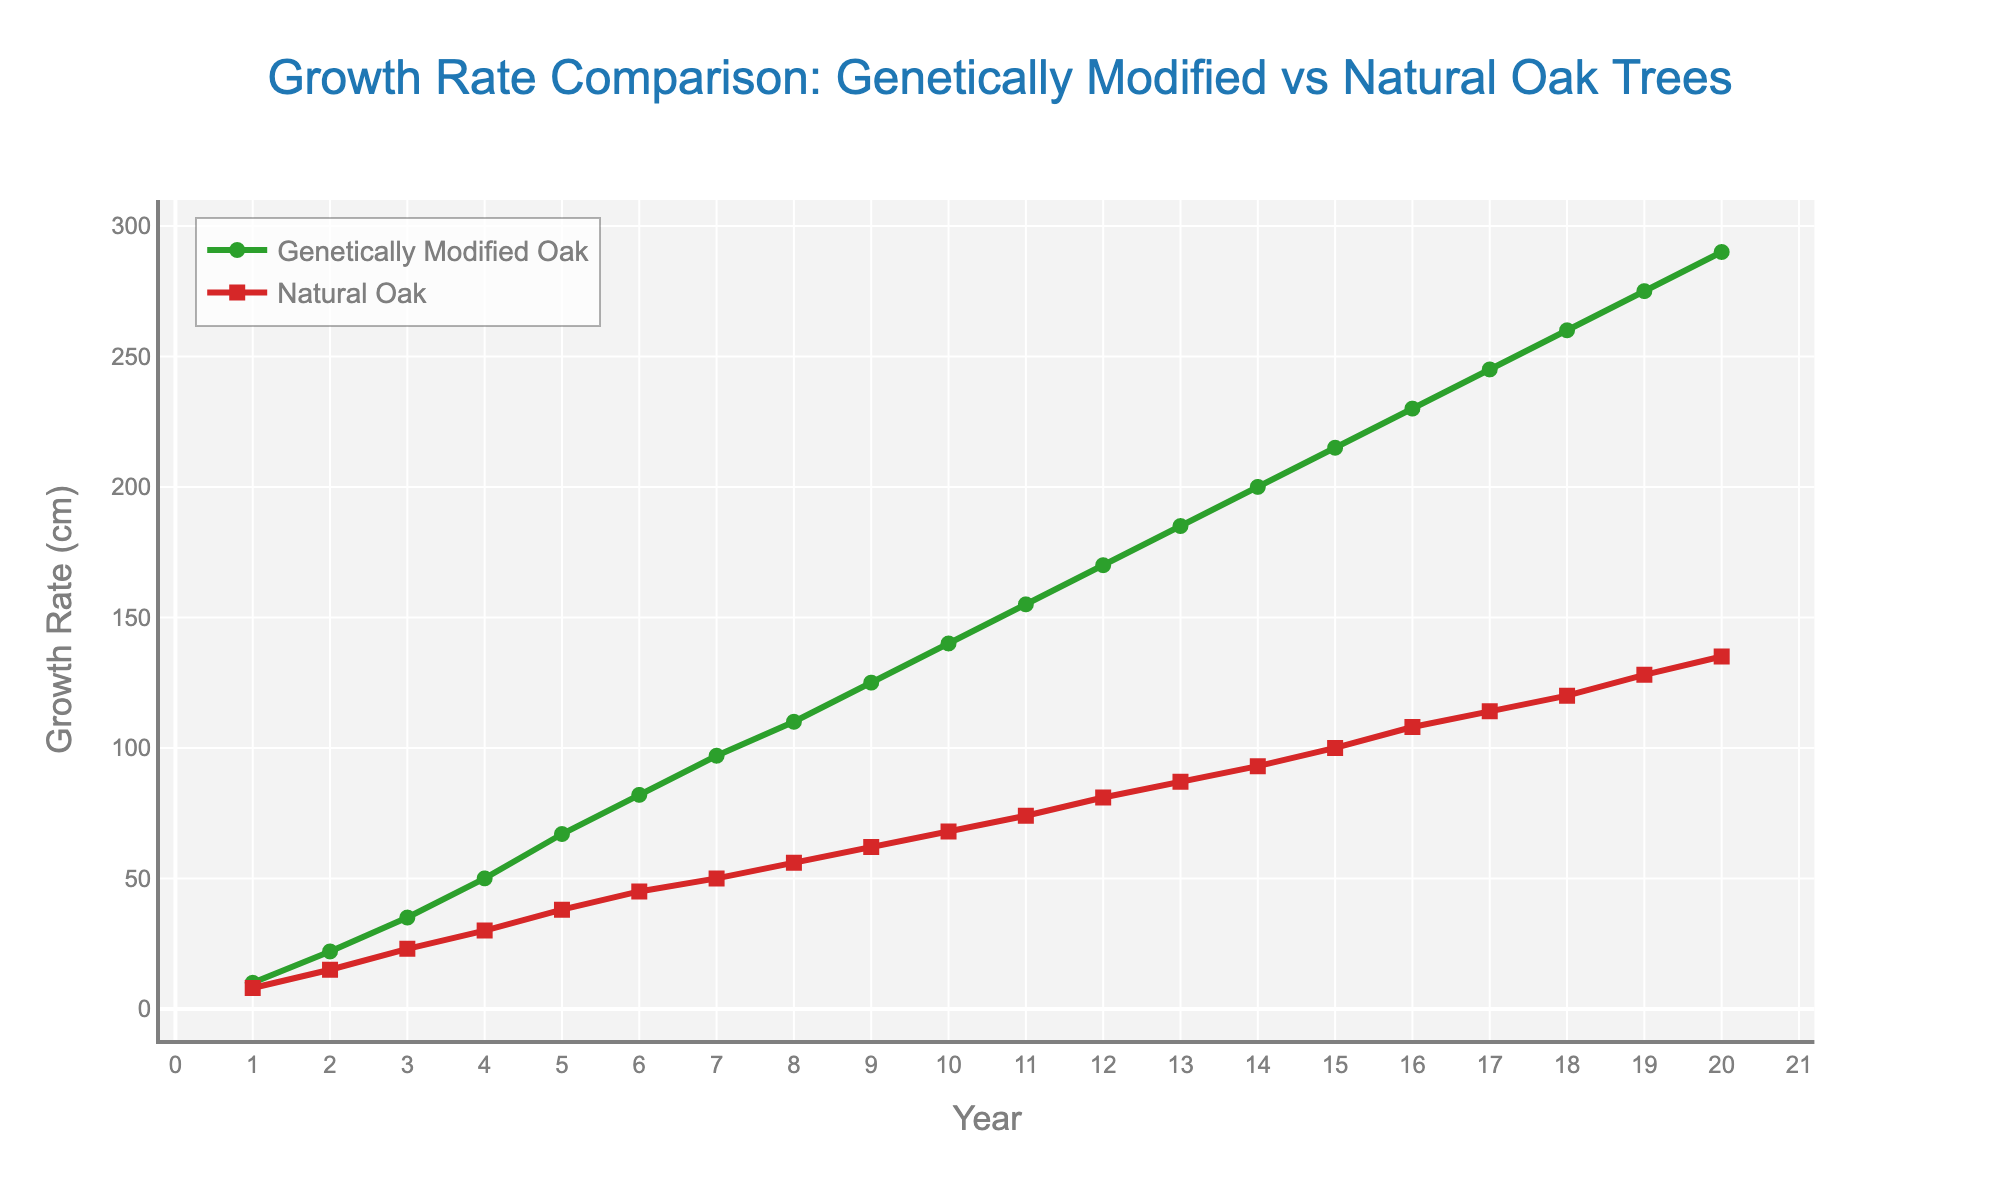What's the title of the plot? The title is displayed prominently at the top center of the plot. It reads "Growth Rate Comparison: Genetically Modified vs Natural Oak Trees".
Answer: Growth Rate Comparison: Genetically Modified vs Natural Oak Trees What do the x-axis and y-axis represent? The x-axis represents the years (from 1 to 20 years), and the y-axis represents the growth rate in centimeters. These labels are found at the axis titles.
Answer: Years, Growth Rate (cm) How many markers are there for each tree type? Each tree type has one marker per year. Since the period is 20 years, there are 20 markers for each type of tree.
Answer: 20 At what year did Genetically Modified Oak trees reach a growth rate of 200 cm? By looking at the Genetically Modified Oak line (green), we find that it reaches 200 cm in year 14.
Answer: Year 14 Which tree type has a higher growth rate in year 5? The growth rate of Genetically Modified Oak trees is 67 cm and for Natural Oak trees it is 38 cm in year 5. The Genetically Modified Oak has a higher growth rate.
Answer: Genetically Modified Oak What is the average growth rate of Natural Oak trees over the 20-year period? Sum the growth rates of Natural Oak trees over 20 years (8 + 15 + 23 + 30 + 38 + 45 + 50 + 56 + 62 + 68 + 74 + 81 + 87 + 93 + 100 + 108 + 114 + 120 + 128 + 135) which equals 1427 cm. Then, divide by 20 years.
Answer: 71.35 cm How does the growth rate of Genetically Modified Oak trees compare to Natural Oak trees at year 10? In year 10, the growth rate of Genetically Modified Oak trees is 140 cm and for Natural Oak trees is 68 cm. Genetically Modified Oak trees have a growth rate that is more than double that of Natural Oak trees in year 10.
Answer: More than double At what years do both tree types exhibit the same growth rate increment? To find similar increments, examine the difference in growth rates year over year for both tree types. In years 1-2, 2-3, and so on, compare their differences. The increments are generally not the same except for matching increments in some individual years with approximate comparison. A definitive exact match increment is not regularly seen from the figure data.
Answer: Not regularly seen Between which years does the difference in growth rate between the two trees become the most pronounced? By examining the difference in growth rates between consecutive years, the most pronounced difference appears to be between years 19 and 20, where the growth rate of Genetically Modified Oak trees increases significantly compared to Natural Oak trees.
Answer: Years 19 and 20 Do both tree types show a linear growth rate trend? Both lines show a generally steady upward trend year over year; however, neither line is strictly linear. Both exhibit a pattern that appears exponentially increasing rather than perfectly linear.
Answer: No 